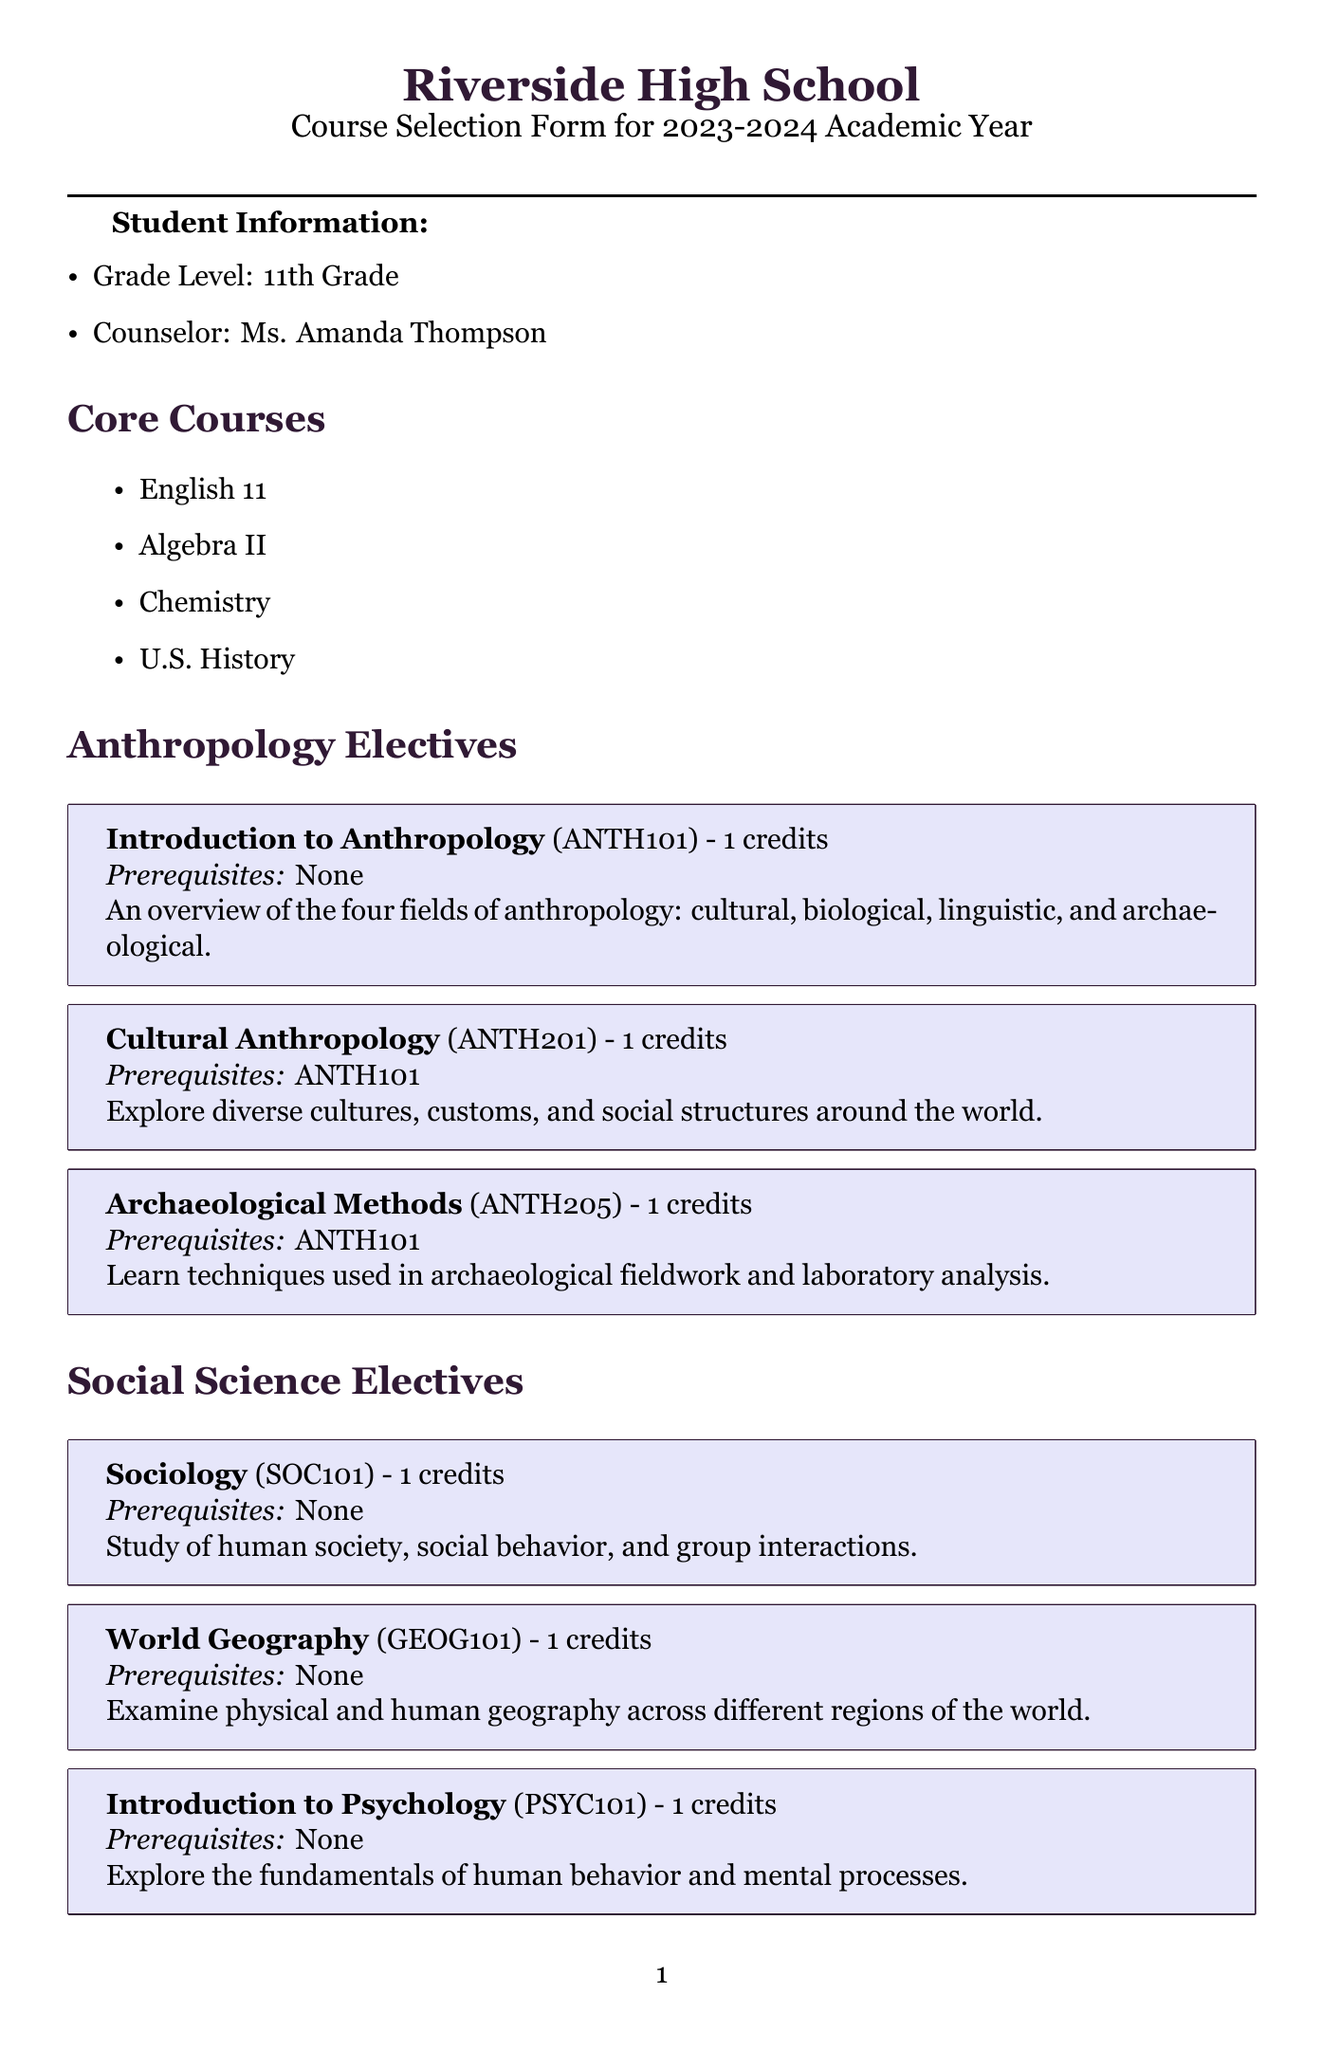What is the school name? The school name is located at the beginning of the document under the title section.
Answer: Riverside High School Who is the counselor? The counselor's name is listed in the student information section of the document.
Answer: Ms. Amanda Thompson What is the submission deadline? The submission deadline is mentioned at the end of the document.
Answer: March 15, 2023 How many credits is "Cultural Anthropology"? The credits for the course are stated in the course description of the anthropology electives section.
Answer: 1 What course is a prerequisite for "Cultural Anthropology"? The prerequisite course is provided in the course description for "Cultural Anthropology".
Answer: ANTH101 How many core courses must a student select? The course selection instructions specify the number of core courses to be selected.
Answer: 4 What is the total limit of credits? The credit limit is indicated in the course selection instructions section of the document.
Answer: 8 What are the names of the extracurricular activities listed? The extracurricular activities are listed in a section of the document dedicated to that topic.
Answer: Anthropology Club, Model United Nations, Debate Team, International Culture Club What is the course code for "Introduction to Psychology"? The course code is provided near the course name in the social science electives section.
Answer: PSYC101 